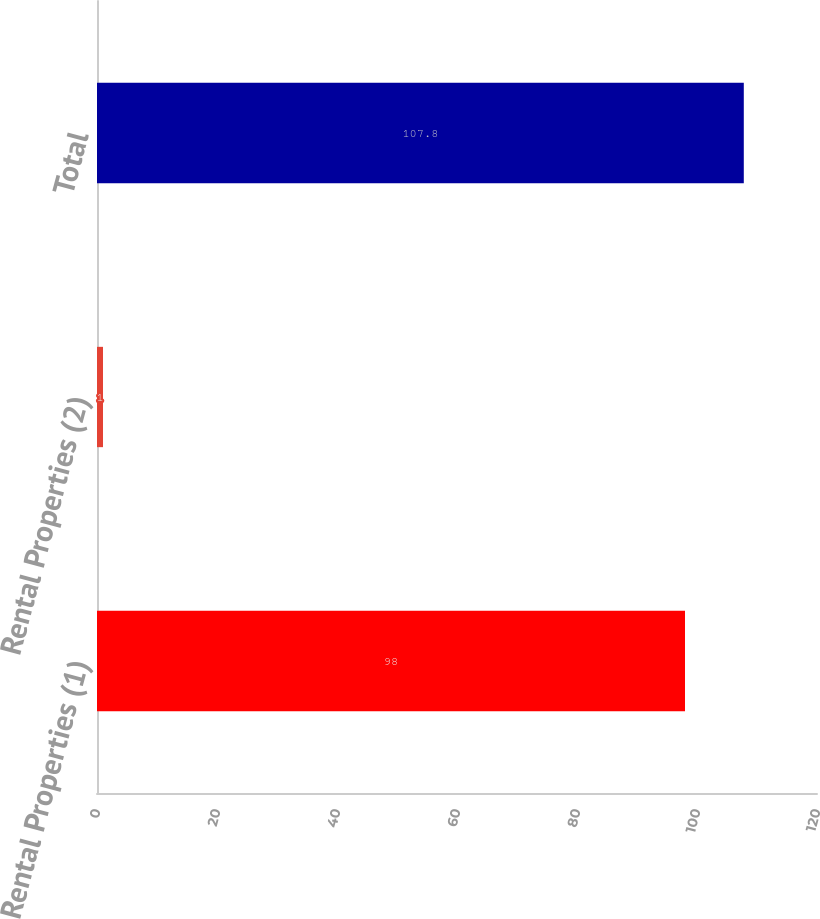Convert chart. <chart><loc_0><loc_0><loc_500><loc_500><bar_chart><fcel>Rental Properties (1)<fcel>Rental Properties (2)<fcel>Total<nl><fcel>98<fcel>1<fcel>107.8<nl></chart> 